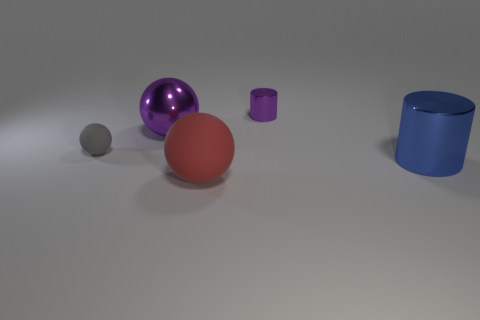Add 4 brown matte cubes. How many objects exist? 9 Subtract all cylinders. How many objects are left? 3 Subtract 0 gray cylinders. How many objects are left? 5 Subtract all spheres. Subtract all red rubber spheres. How many objects are left? 1 Add 1 cylinders. How many cylinders are left? 3 Add 4 blue metallic things. How many blue metallic things exist? 5 